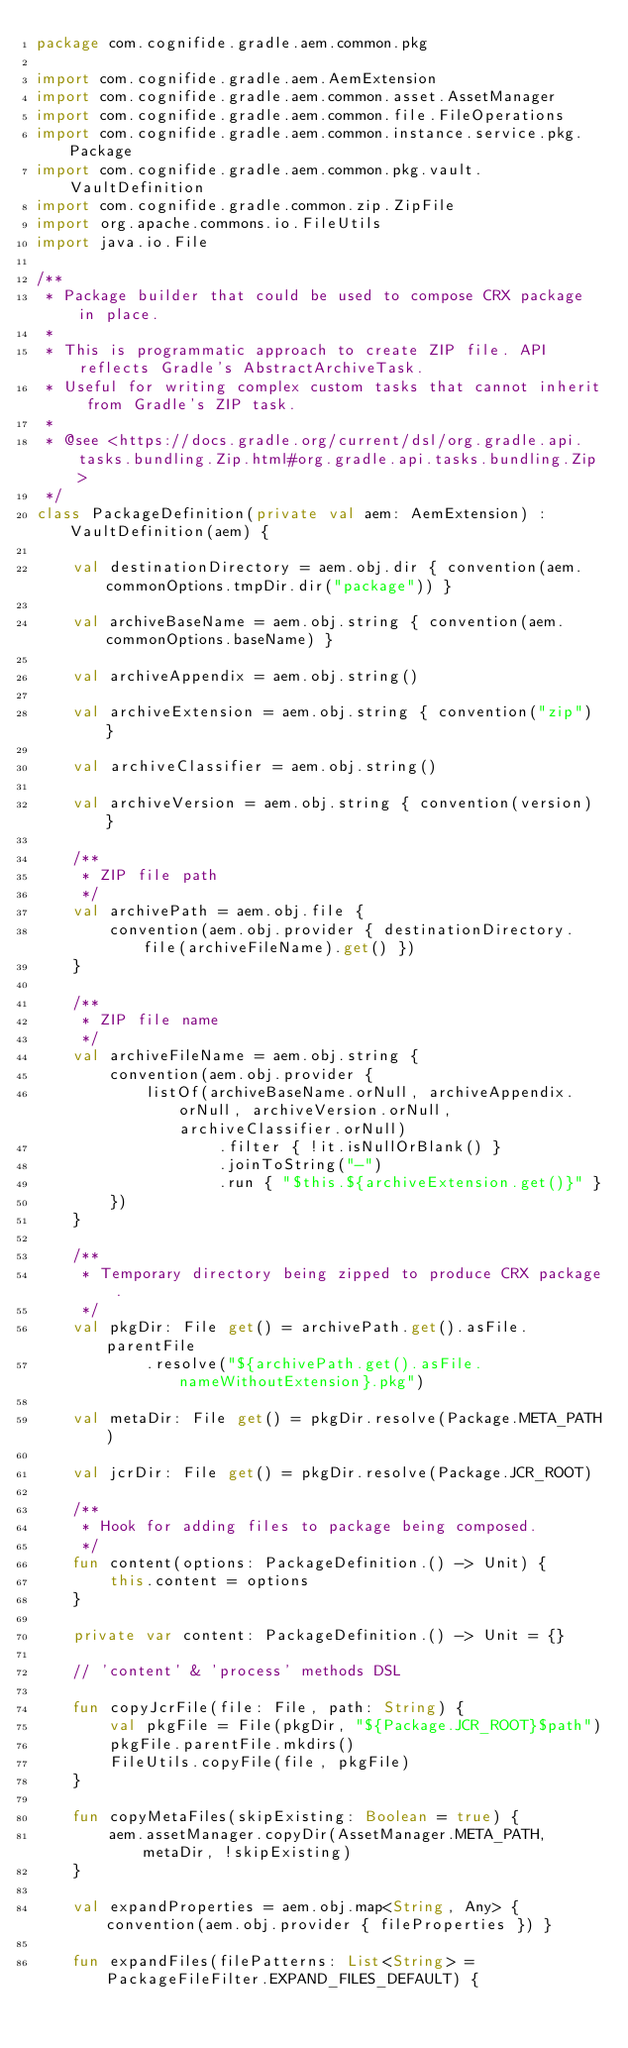Convert code to text. <code><loc_0><loc_0><loc_500><loc_500><_Kotlin_>package com.cognifide.gradle.aem.common.pkg

import com.cognifide.gradle.aem.AemExtension
import com.cognifide.gradle.aem.common.asset.AssetManager
import com.cognifide.gradle.aem.common.file.FileOperations
import com.cognifide.gradle.aem.common.instance.service.pkg.Package
import com.cognifide.gradle.aem.common.pkg.vault.VaultDefinition
import com.cognifide.gradle.common.zip.ZipFile
import org.apache.commons.io.FileUtils
import java.io.File

/**
 * Package builder that could be used to compose CRX package in place.
 *
 * This is programmatic approach to create ZIP file. API reflects Gradle's AbstractArchiveTask.
 * Useful for writing complex custom tasks that cannot inherit from Gradle's ZIP task.
 *
 * @see <https://docs.gradle.org/current/dsl/org.gradle.api.tasks.bundling.Zip.html#org.gradle.api.tasks.bundling.Zip>
 */
class PackageDefinition(private val aem: AemExtension) : VaultDefinition(aem) {

    val destinationDirectory = aem.obj.dir { convention(aem.commonOptions.tmpDir.dir("package")) }

    val archiveBaseName = aem.obj.string { convention(aem.commonOptions.baseName) }

    val archiveAppendix = aem.obj.string()

    val archiveExtension = aem.obj.string { convention("zip") }

    val archiveClassifier = aem.obj.string()

    val archiveVersion = aem.obj.string { convention(version) }

    /**
     * ZIP file path
     */
    val archivePath = aem.obj.file {
        convention(aem.obj.provider { destinationDirectory.file(archiveFileName).get() })
    }

    /**
     * ZIP file name
     */
    val archiveFileName = aem.obj.string {
        convention(aem.obj.provider {
            listOf(archiveBaseName.orNull, archiveAppendix.orNull, archiveVersion.orNull, archiveClassifier.orNull)
                    .filter { !it.isNullOrBlank() }
                    .joinToString("-")
                    .run { "$this.${archiveExtension.get()}" }
        })
    }

    /**
     * Temporary directory being zipped to produce CRX package.
     */
    val pkgDir: File get() = archivePath.get().asFile.parentFile
            .resolve("${archivePath.get().asFile.nameWithoutExtension}.pkg")

    val metaDir: File get() = pkgDir.resolve(Package.META_PATH)

    val jcrDir: File get() = pkgDir.resolve(Package.JCR_ROOT)

    /**
     * Hook for adding files to package being composed.
     */
    fun content(options: PackageDefinition.() -> Unit) {
        this.content = options
    }

    private var content: PackageDefinition.() -> Unit = {}

    // 'content' & 'process' methods DSL

    fun copyJcrFile(file: File, path: String) {
        val pkgFile = File(pkgDir, "${Package.JCR_ROOT}$path")
        pkgFile.parentFile.mkdirs()
        FileUtils.copyFile(file, pkgFile)
    }

    fun copyMetaFiles(skipExisting: Boolean = true) {
        aem.assetManager.copyDir(AssetManager.META_PATH, metaDir, !skipExisting)
    }

    val expandProperties = aem.obj.map<String, Any> { convention(aem.obj.provider { fileProperties }) }

    fun expandFiles(filePatterns: List<String> = PackageFileFilter.EXPAND_FILES_DEFAULT) {</code> 